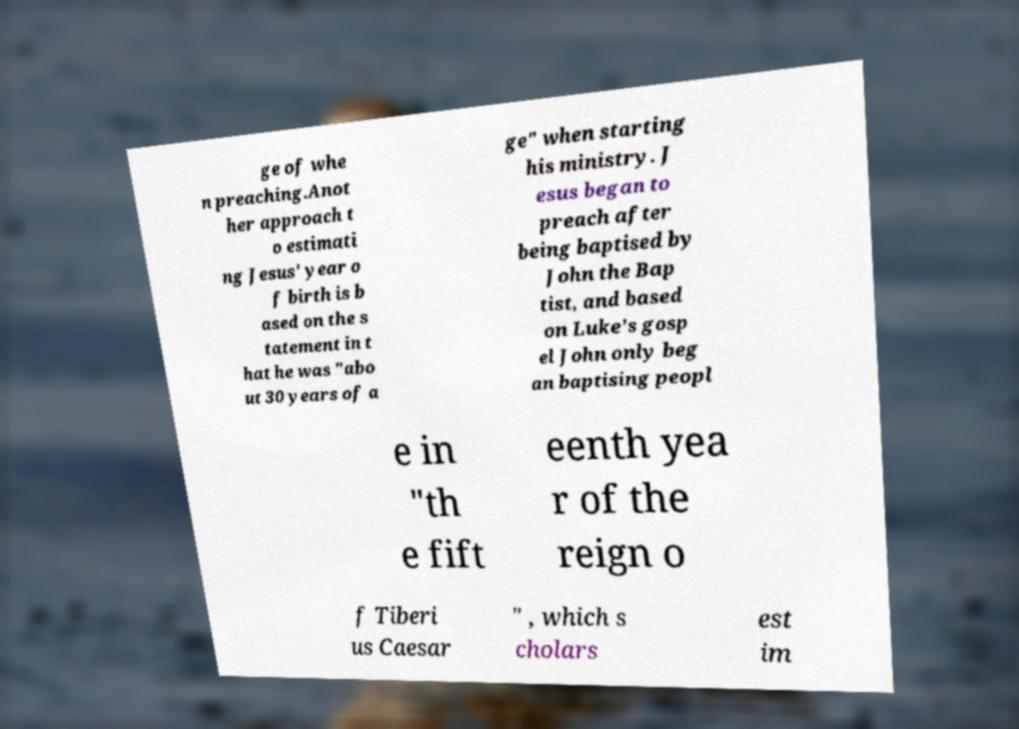For documentation purposes, I need the text within this image transcribed. Could you provide that? ge of whe n preaching.Anot her approach t o estimati ng Jesus' year o f birth is b ased on the s tatement in t hat he was "abo ut 30 years of a ge" when starting his ministry. J esus began to preach after being baptised by John the Bap tist, and based on Luke’s gosp el John only beg an baptising peopl e in "th e fift eenth yea r of the reign o f Tiberi us Caesar " , which s cholars est im 